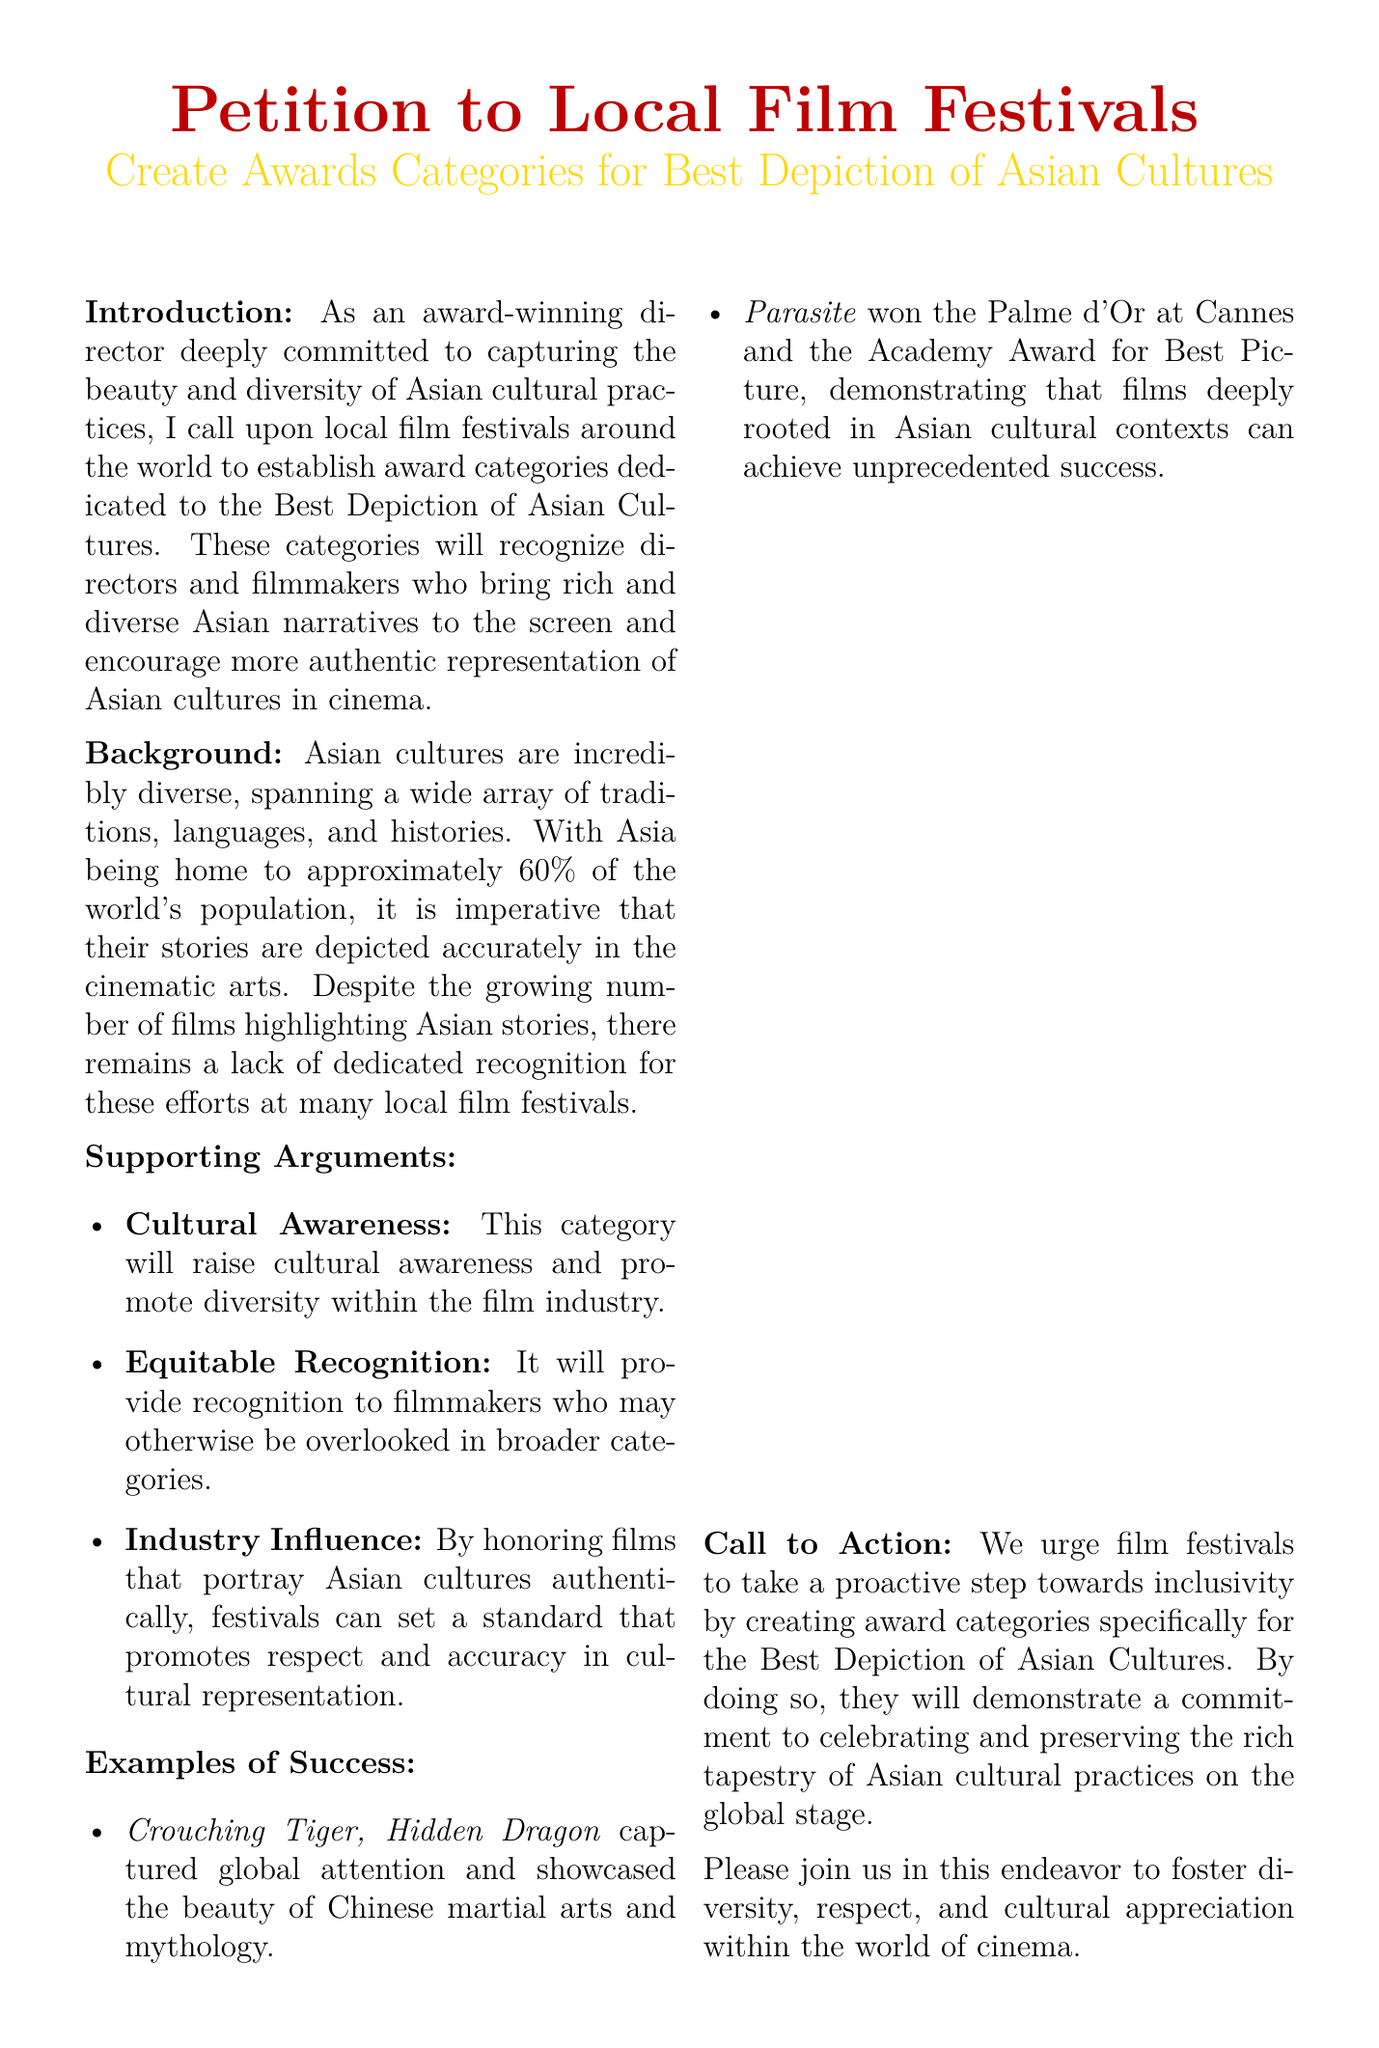What is the main purpose of the petition? The petition aims to establish award categories for the Best Depiction of Asian Cultures at local film festivals.
Answer: Establish award categories for the Best Depiction of Asian Cultures Who is the petition aimed at? The petition is directed towards local film festivals around the world.
Answer: Local film festivals What percentage of the world's population is approximately from Asia? The document states that Asia is home to approximately 60% of the world's population.
Answer: 60% Name one film mentioned as a successful depiction of Asian culture. The document cites "Crouching Tiger, Hidden Dragon" as an example of success.
Answer: Crouching Tiger, Hidden Dragon What is one of the supporting arguments for creating these award categories? One supporting argument is that it will raise cultural awareness and promote diversity within the film industry.
Answer: Raise cultural awareness Why should festivals honor films portraying Asian cultures authentically? By doing so, festivals can promote respect and accuracy in cultural representation.
Answer: Promote respect and accuracy What does the petition urge festivals to demonstrate through the creation of these categories? The petition urges festivals to demonstrate a commitment to celebrating and preserving Asian cultural practices.
Answer: Commitment to celebrating and preserving What does the document suggest will be a benefit for filmmakers? It proposes that filmmakers who may otherwise be overlooked will receive recognition.
Answer: Recognition How can individuals support the petition? Individuals can sign the petition, providing their name, email, signature, and date.
Answer: Sign the petition 